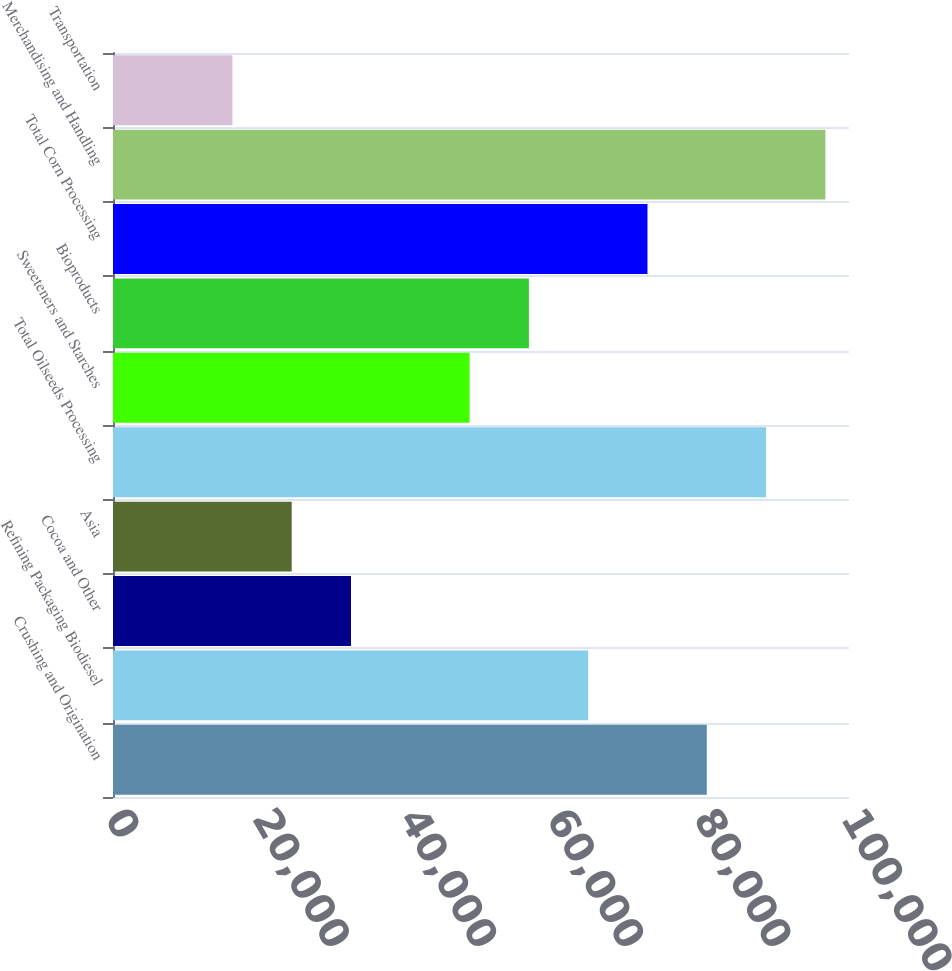Convert chart to OTSL. <chart><loc_0><loc_0><loc_500><loc_500><bar_chart><fcel>Crushing and Origination<fcel>Refining Packaging Biodiesel<fcel>Cocoa and Other<fcel>Asia<fcel>Total Oilseeds Processing<fcel>Sweeteners and Starches<fcel>Bioproducts<fcel>Total Corn Processing<fcel>Merchandising and Handling<fcel>Transportation<nl><fcel>80676<fcel>64562.8<fcel>32336.4<fcel>24279.8<fcel>88732.6<fcel>48449.6<fcel>56506.2<fcel>72619.4<fcel>96789.2<fcel>16223.2<nl></chart> 